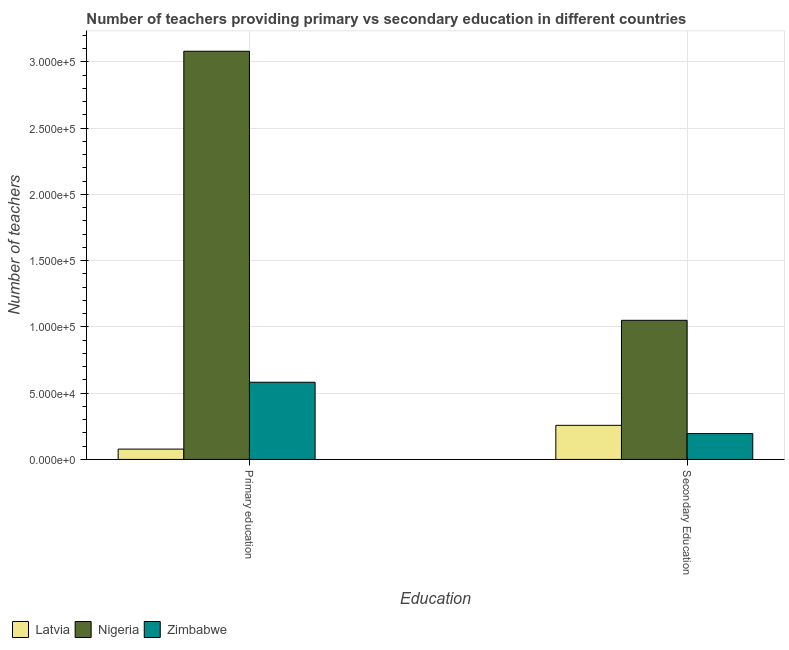How many groups of bars are there?
Provide a succinct answer. 2. Are the number of bars per tick equal to the number of legend labels?
Provide a succinct answer. Yes. Are the number of bars on each tick of the X-axis equal?
Your answer should be compact. Yes. How many bars are there on the 2nd tick from the left?
Offer a terse response. 3. What is the label of the 2nd group of bars from the left?
Your answer should be compact. Secondary Education. What is the number of secondary teachers in Zimbabwe?
Offer a very short reply. 1.95e+04. Across all countries, what is the maximum number of primary teachers?
Your answer should be very brief. 3.08e+05. Across all countries, what is the minimum number of primary teachers?
Offer a terse response. 7788. In which country was the number of secondary teachers maximum?
Your response must be concise. Nigeria. In which country was the number of secondary teachers minimum?
Your response must be concise. Zimbabwe. What is the total number of primary teachers in the graph?
Keep it short and to the point. 3.74e+05. What is the difference between the number of secondary teachers in Zimbabwe and that in Nigeria?
Ensure brevity in your answer.  -8.55e+04. What is the difference between the number of secondary teachers in Latvia and the number of primary teachers in Zimbabwe?
Your answer should be compact. -3.25e+04. What is the average number of secondary teachers per country?
Make the answer very short. 5.01e+04. What is the difference between the number of primary teachers and number of secondary teachers in Latvia?
Your answer should be very brief. -1.79e+04. In how many countries, is the number of primary teachers greater than 100000 ?
Ensure brevity in your answer.  1. What is the ratio of the number of secondary teachers in Zimbabwe to that in Latvia?
Offer a very short reply. 0.76. Is the number of secondary teachers in Nigeria less than that in Latvia?
Your response must be concise. No. In how many countries, is the number of primary teachers greater than the average number of primary teachers taken over all countries?
Offer a very short reply. 1. What does the 1st bar from the left in Secondary Education represents?
Your answer should be compact. Latvia. What does the 3rd bar from the right in Secondary Education represents?
Your response must be concise. Latvia. How many bars are there?
Keep it short and to the point. 6. Are the values on the major ticks of Y-axis written in scientific E-notation?
Make the answer very short. Yes. Where does the legend appear in the graph?
Provide a succinct answer. Bottom left. How many legend labels are there?
Make the answer very short. 3. What is the title of the graph?
Offer a very short reply. Number of teachers providing primary vs secondary education in different countries. What is the label or title of the X-axis?
Your answer should be very brief. Education. What is the label or title of the Y-axis?
Offer a terse response. Number of teachers. What is the Number of teachers of Latvia in Primary education?
Keep it short and to the point. 7788. What is the Number of teachers in Nigeria in Primary education?
Provide a succinct answer. 3.08e+05. What is the Number of teachers in Zimbabwe in Primary education?
Provide a succinct answer. 5.83e+04. What is the Number of teachers in Latvia in Secondary Education?
Provide a succinct answer. 2.57e+04. What is the Number of teachers in Nigeria in Secondary Education?
Offer a very short reply. 1.05e+05. What is the Number of teachers of Zimbabwe in Secondary Education?
Offer a very short reply. 1.95e+04. Across all Education, what is the maximum Number of teachers of Latvia?
Provide a succinct answer. 2.57e+04. Across all Education, what is the maximum Number of teachers of Nigeria?
Ensure brevity in your answer.  3.08e+05. Across all Education, what is the maximum Number of teachers in Zimbabwe?
Provide a succinct answer. 5.83e+04. Across all Education, what is the minimum Number of teachers in Latvia?
Offer a terse response. 7788. Across all Education, what is the minimum Number of teachers of Nigeria?
Your response must be concise. 1.05e+05. Across all Education, what is the minimum Number of teachers in Zimbabwe?
Ensure brevity in your answer.  1.95e+04. What is the total Number of teachers in Latvia in the graph?
Your answer should be very brief. 3.35e+04. What is the total Number of teachers of Nigeria in the graph?
Offer a terse response. 4.13e+05. What is the total Number of teachers of Zimbabwe in the graph?
Keep it short and to the point. 7.78e+04. What is the difference between the Number of teachers of Latvia in Primary education and that in Secondary Education?
Ensure brevity in your answer.  -1.79e+04. What is the difference between the Number of teachers of Nigeria in Primary education and that in Secondary Education?
Provide a short and direct response. 2.03e+05. What is the difference between the Number of teachers of Zimbabwe in Primary education and that in Secondary Education?
Provide a short and direct response. 3.88e+04. What is the difference between the Number of teachers in Latvia in Primary education and the Number of teachers in Nigeria in Secondary Education?
Give a very brief answer. -9.72e+04. What is the difference between the Number of teachers in Latvia in Primary education and the Number of teachers in Zimbabwe in Secondary Education?
Provide a short and direct response. -1.17e+04. What is the difference between the Number of teachers of Nigeria in Primary education and the Number of teachers of Zimbabwe in Secondary Education?
Your answer should be very brief. 2.89e+05. What is the average Number of teachers in Latvia per Education?
Keep it short and to the point. 1.68e+04. What is the average Number of teachers in Nigeria per Education?
Offer a very short reply. 2.07e+05. What is the average Number of teachers of Zimbabwe per Education?
Offer a terse response. 3.89e+04. What is the difference between the Number of teachers in Latvia and Number of teachers in Nigeria in Primary education?
Your answer should be compact. -3.00e+05. What is the difference between the Number of teachers in Latvia and Number of teachers in Zimbabwe in Primary education?
Your answer should be compact. -5.05e+04. What is the difference between the Number of teachers of Nigeria and Number of teachers of Zimbabwe in Primary education?
Offer a very short reply. 2.50e+05. What is the difference between the Number of teachers in Latvia and Number of teachers in Nigeria in Secondary Education?
Offer a terse response. -7.93e+04. What is the difference between the Number of teachers of Latvia and Number of teachers of Zimbabwe in Secondary Education?
Make the answer very short. 6222. What is the difference between the Number of teachers of Nigeria and Number of teachers of Zimbabwe in Secondary Education?
Provide a short and direct response. 8.55e+04. What is the ratio of the Number of teachers of Latvia in Primary education to that in Secondary Education?
Your response must be concise. 0.3. What is the ratio of the Number of teachers of Nigeria in Primary education to that in Secondary Education?
Your answer should be very brief. 2.93. What is the ratio of the Number of teachers of Zimbabwe in Primary education to that in Secondary Education?
Keep it short and to the point. 2.99. What is the difference between the highest and the second highest Number of teachers of Latvia?
Your answer should be very brief. 1.79e+04. What is the difference between the highest and the second highest Number of teachers in Nigeria?
Make the answer very short. 2.03e+05. What is the difference between the highest and the second highest Number of teachers in Zimbabwe?
Offer a terse response. 3.88e+04. What is the difference between the highest and the lowest Number of teachers of Latvia?
Your answer should be compact. 1.79e+04. What is the difference between the highest and the lowest Number of teachers in Nigeria?
Your response must be concise. 2.03e+05. What is the difference between the highest and the lowest Number of teachers in Zimbabwe?
Offer a very short reply. 3.88e+04. 